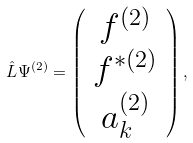Convert formula to latex. <formula><loc_0><loc_0><loc_500><loc_500>\hat { L } \Psi ^ { ( 2 ) } = \left ( \begin{array} { c } f ^ { ( 2 ) } \\ f ^ { \ast ( 2 ) } \\ a ^ { ( 2 ) } _ { k } \end{array} \right ) ,</formula> 